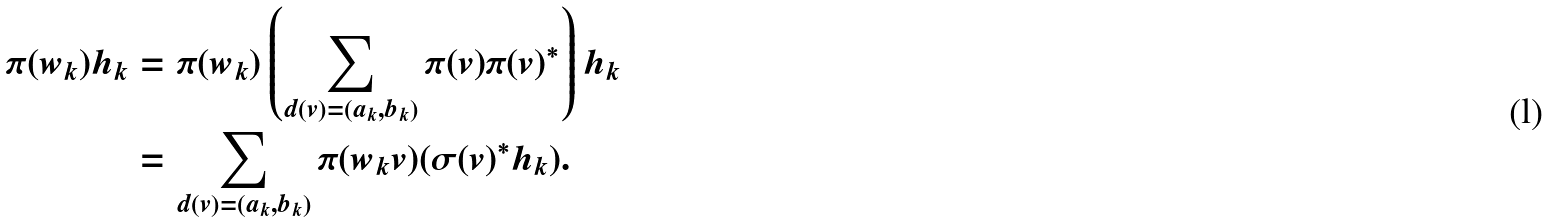Convert formula to latex. <formula><loc_0><loc_0><loc_500><loc_500>\pi ( w _ { k } ) h _ { k } & = \pi ( w _ { k } ) \left ( \sum _ { d ( v ) = ( a _ { k } , b _ { k } ) } \pi ( v ) \pi ( v ) ^ { * } \right ) h _ { k } \\ & = \sum _ { d ( v ) = ( a _ { k } , b _ { k } ) } \pi ( w _ { k } v ) ( \sigma ( v ) ^ { * } h _ { k } ) .</formula> 